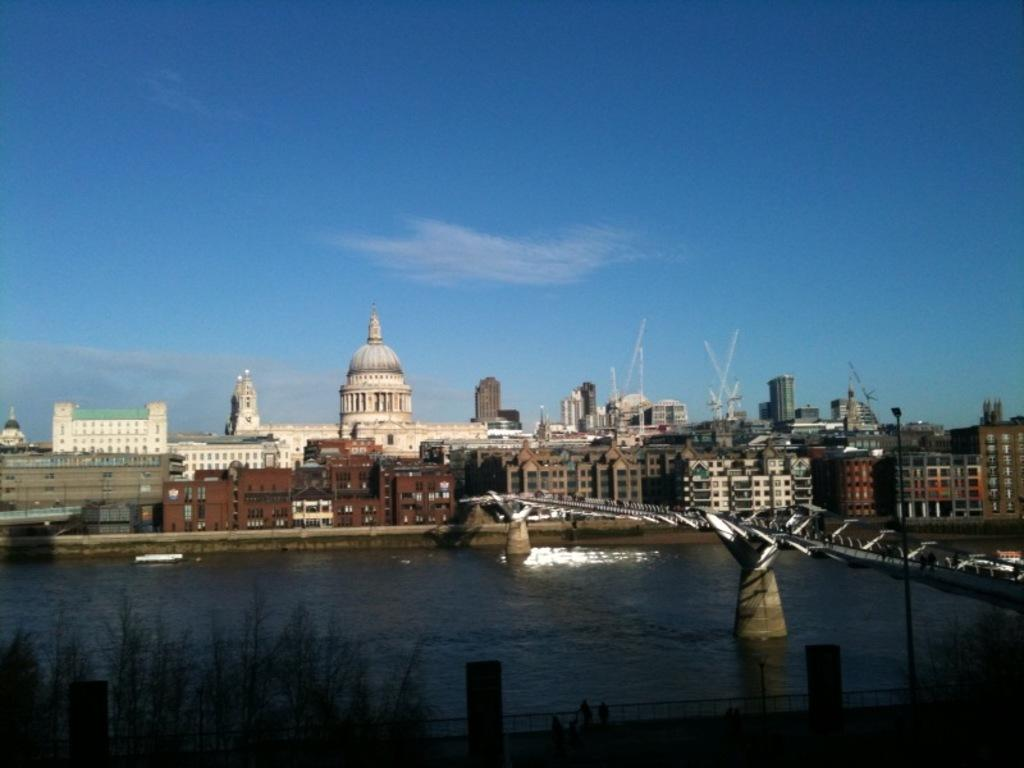What can be seen in the image? There are many buildings, water, a bridge, and clouds visible in the sky. Where is the bridge located in the image? The bridge is on the right side of the image. What is in the middle of the image? There is water in the middle of the image. What is visible in the sky at the top of the image? There are clouds visible in the sky. What type of vegetable is being used as a mask by the fireman in the image? There is no vegetable, mask, or fireman present in the image. 